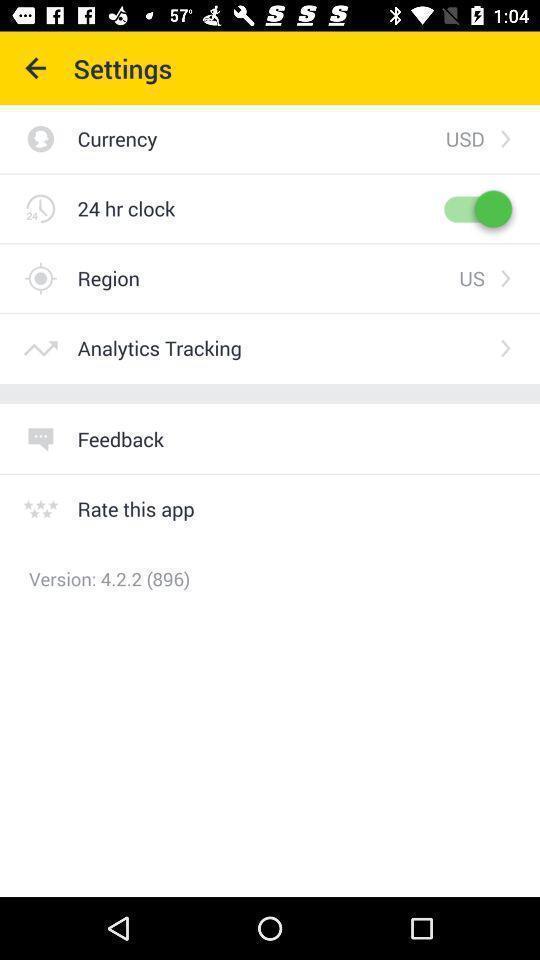Describe the content in this image. Settings page of application with different options in travel app. 